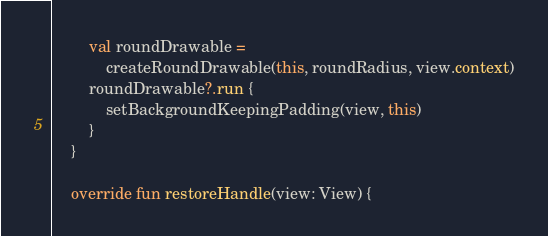Convert code to text. <code><loc_0><loc_0><loc_500><loc_500><_Kotlin_>        val roundDrawable =
            createRoundDrawable(this, roundRadius, view.context)
        roundDrawable?.run {
            setBackgroundKeepingPadding(view, this)
        }
    }

    override fun restoreHandle(view: View) {</code> 